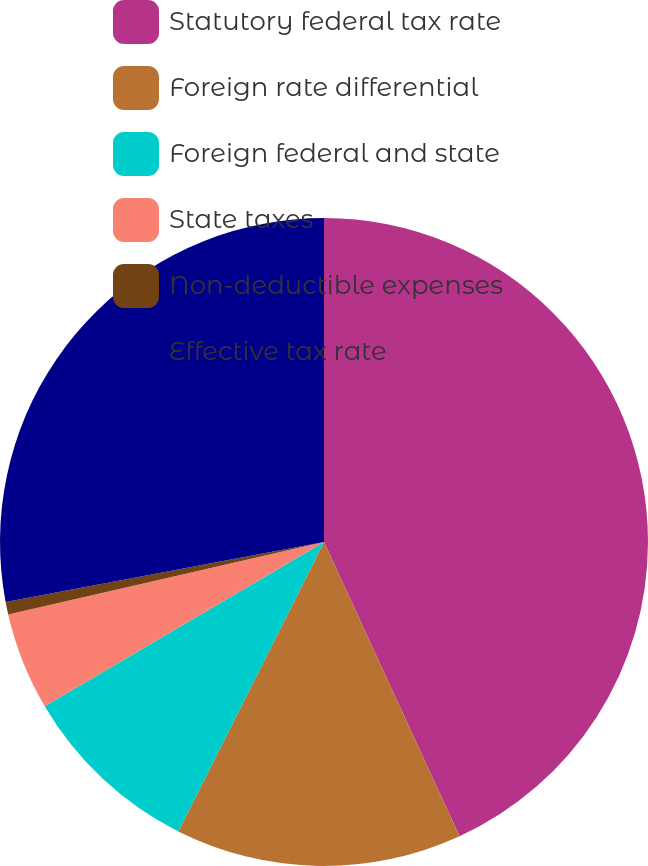Convert chart to OTSL. <chart><loc_0><loc_0><loc_500><loc_500><pie_chart><fcel>Statutory federal tax rate<fcel>Foreign rate differential<fcel>Foreign federal and state<fcel>State taxes<fcel>Non-deductible expenses<fcel>Effective tax rate<nl><fcel>43.13%<fcel>14.29%<fcel>9.12%<fcel>4.87%<fcel>0.62%<fcel>27.97%<nl></chart> 